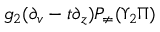<formula> <loc_0><loc_0><loc_500><loc_500>g _ { 2 } ( \partial _ { v } - t \partial _ { z } ) P _ { \neq } ( \Upsilon _ { 2 } \Pi )</formula> 